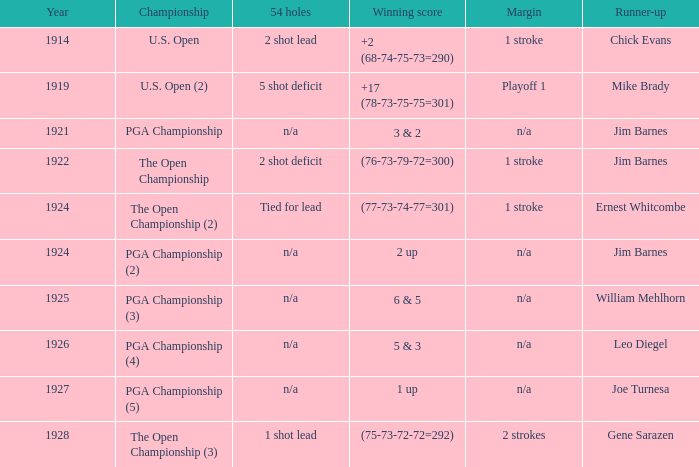WHAT WAS THE YEAR WHEN THE RUNNER-UP WAS WILLIAM MEHLHORN? 1925.0. 